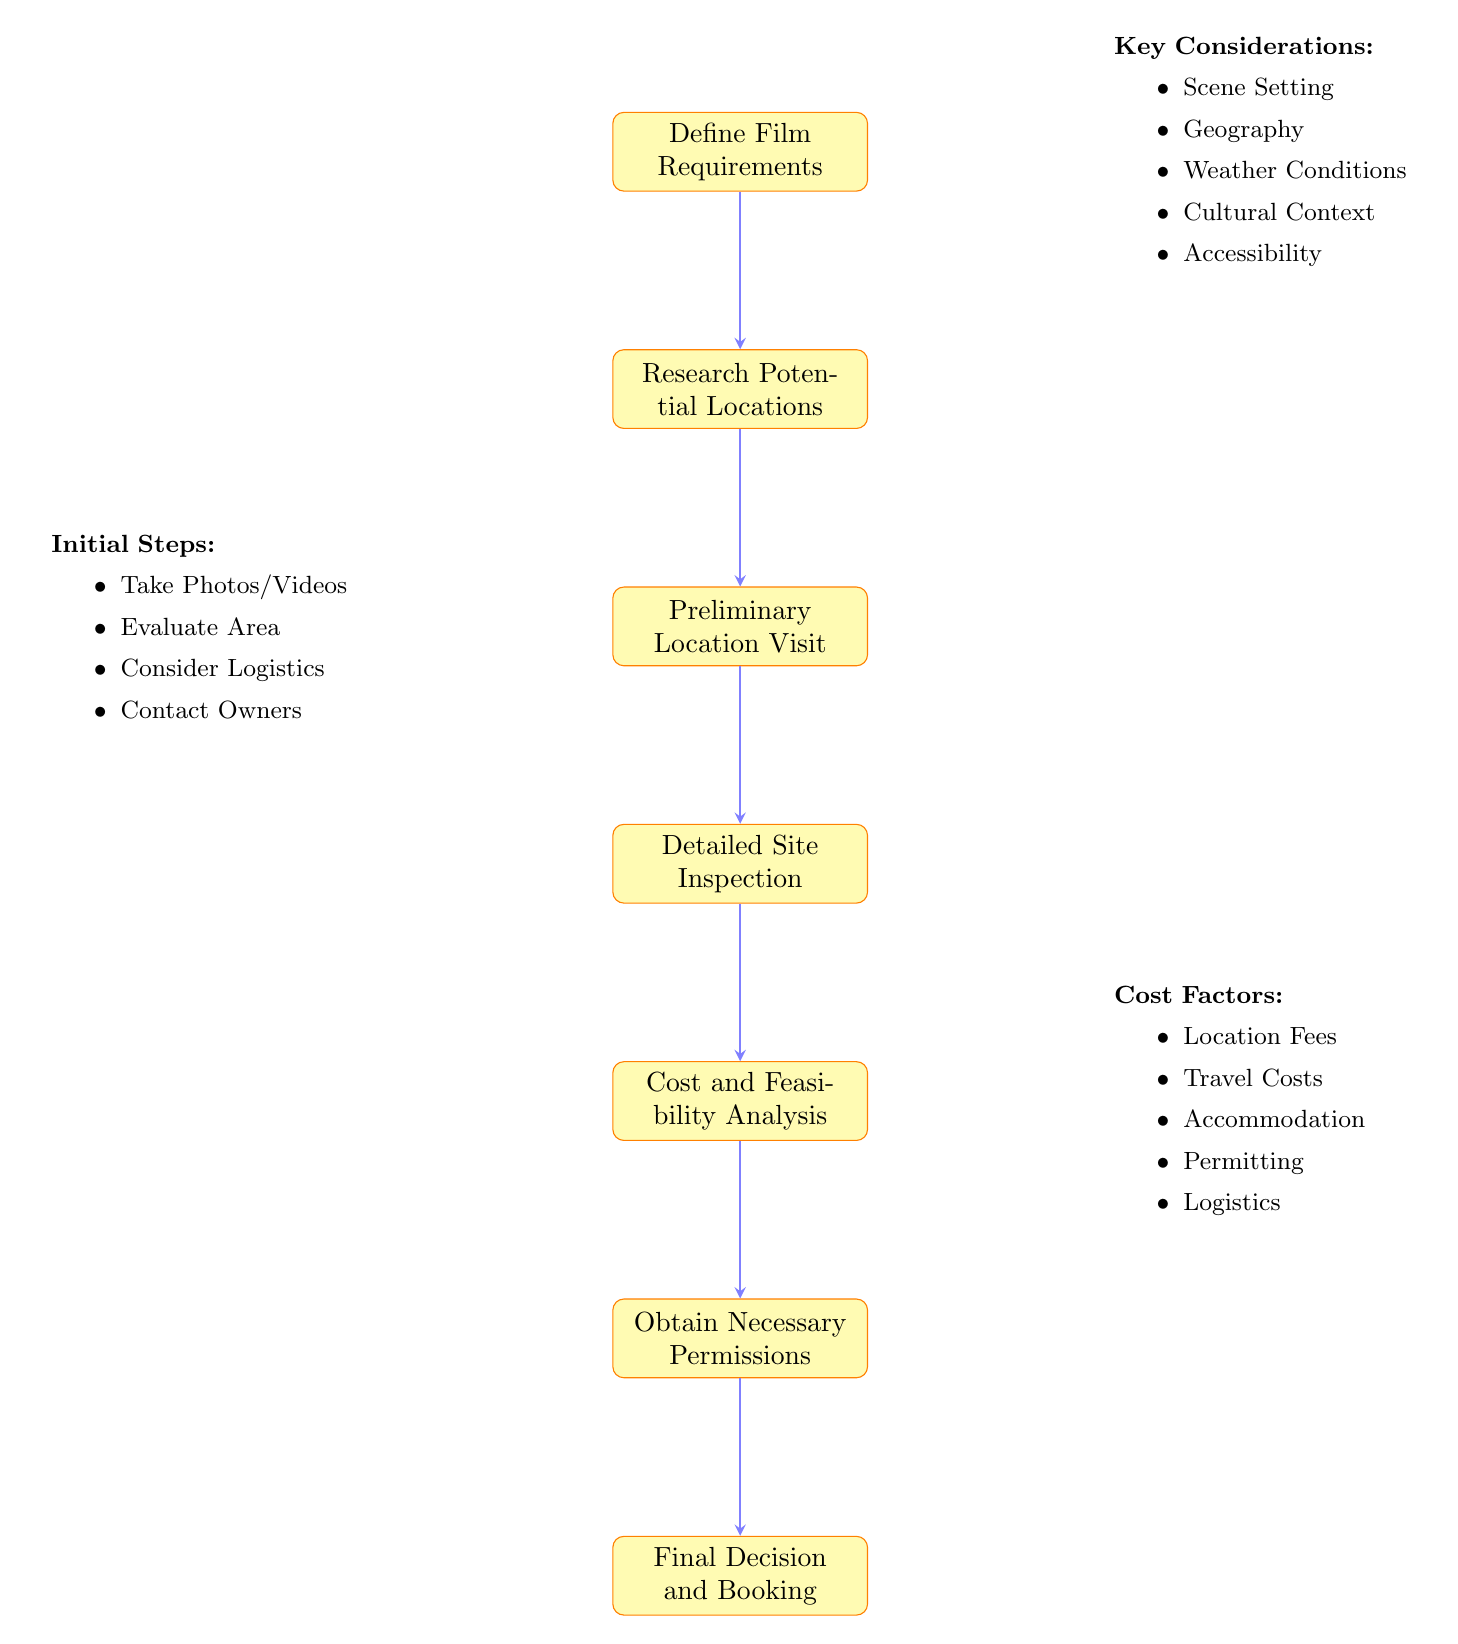What is the first step in the flow chart? The flow chart starts with the node labeled "Define Film Requirements," which indicates the initial step in the process of scouting and evaluating film locations.
Answer: Define Film Requirements How many steps are there in total in the diagram? There are seven distinct steps outlined in the flow chart from "Define Film Requirements" to "Final Decision and Booking," counting each process sequentially.
Answer: Seven What is the last step before obtaining permissions? The step immediately before "Obtain Necessary Permissions" is "Cost and Feasibility Analysis," making it the last step to complete prior to securing permissions.
Answer: Cost and Feasibility Analysis What type of information is considered in the "Define Film Requirements" step? The "Define Film Requirements" step details several key aspects, including scene setting, geography, weather conditions, cultural context, and accessibility, which inform the selection process.
Answer: Scene Setting, Geography, Weather Conditions, Cultural Context, Accessibility What step follows the "Detailed Site Inspection"? The step that follows "Detailed Site Inspection" is "Cost and Feasibility Analysis," indicating a sequence where inspections are followed by financial evaluations.
Answer: Cost and Feasibility Analysis Which step involves evaluating ambient sounds? The step entailing the evaluation of ambient sounds is "Detailed Site Inspection," where multiple site characteristics, including sound and lighting, are assessed for suitability.
Answer: Detailed Site Inspection What information is collected during the "Preliminary Location Visit"? During the "Preliminary Location Visit," initial photos and videos are taken, the surrounding area is evaluated, logistics are considered, and initial contact with owners or managers is established.
Answer: Take Initial Photos and Videos, Evaluate Surrounding Area, Consider Logistics, Initial Contact with Owners/Managers What costs are analyzed in the "Cost and Feasibility Analysis" step? The "Cost and Feasibility Analysis" step analyzes various financial factors, including location fees, travel costs, accommodation for crew, permitting costs, and logistical expenses, which are essential for decision-making.
Answer: Location Fees, Travel Costs, Accommodation for Crew, Permitting Costs, Logistical Expenses 